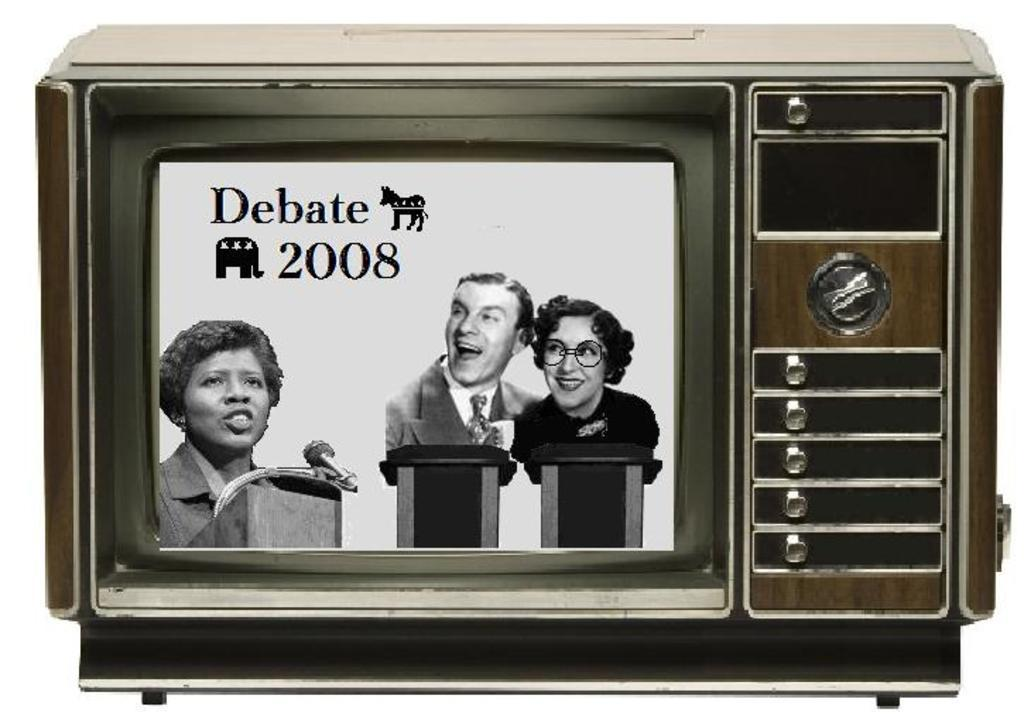<image>
Give a short and clear explanation of the subsequent image. A TV displays a screen for "Debate 2008." 